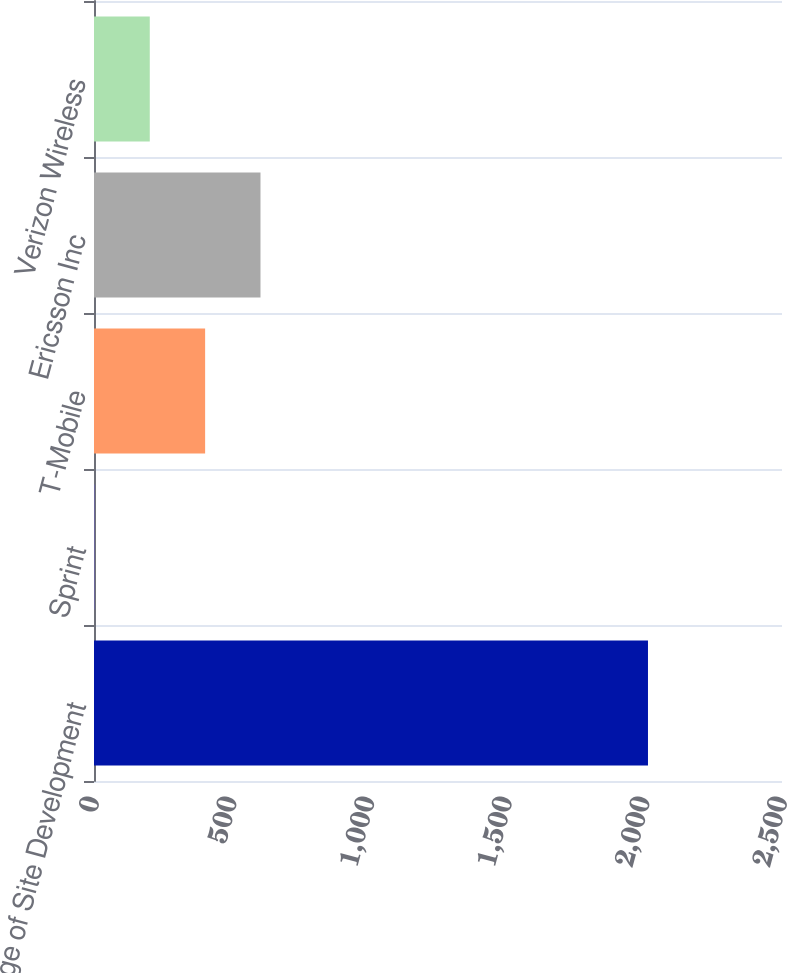Convert chart. <chart><loc_0><loc_0><loc_500><loc_500><bar_chart><fcel>Percentage of Site Development<fcel>Sprint<fcel>T-Mobile<fcel>Ericsson Inc<fcel>Verizon Wireless<nl><fcel>2013<fcel>1.5<fcel>403.8<fcel>604.95<fcel>202.65<nl></chart> 